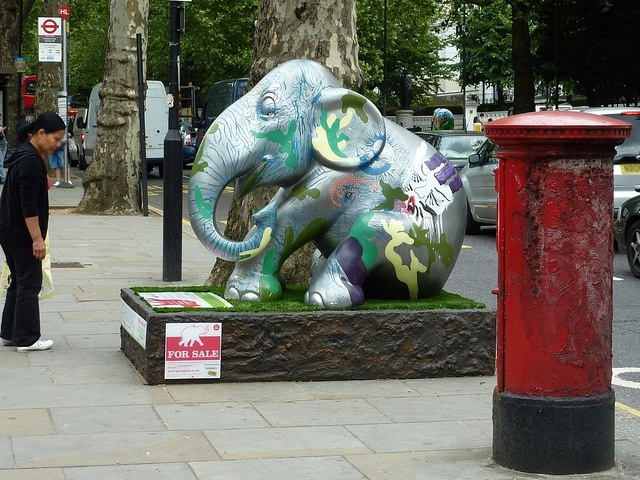Describe the objects in this image and their specific colors. I can see elephant in black, white, gray, and darkgray tones, people in black, brown, maroon, and gray tones, car in black, gray, darkgray, and white tones, truck in black, lightblue, gray, and darkgray tones, and car in black, gray, darkgray, and white tones in this image. 